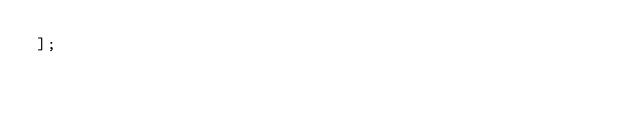Convert code to text. <code><loc_0><loc_0><loc_500><loc_500><_JavaScript_>];
</code> 